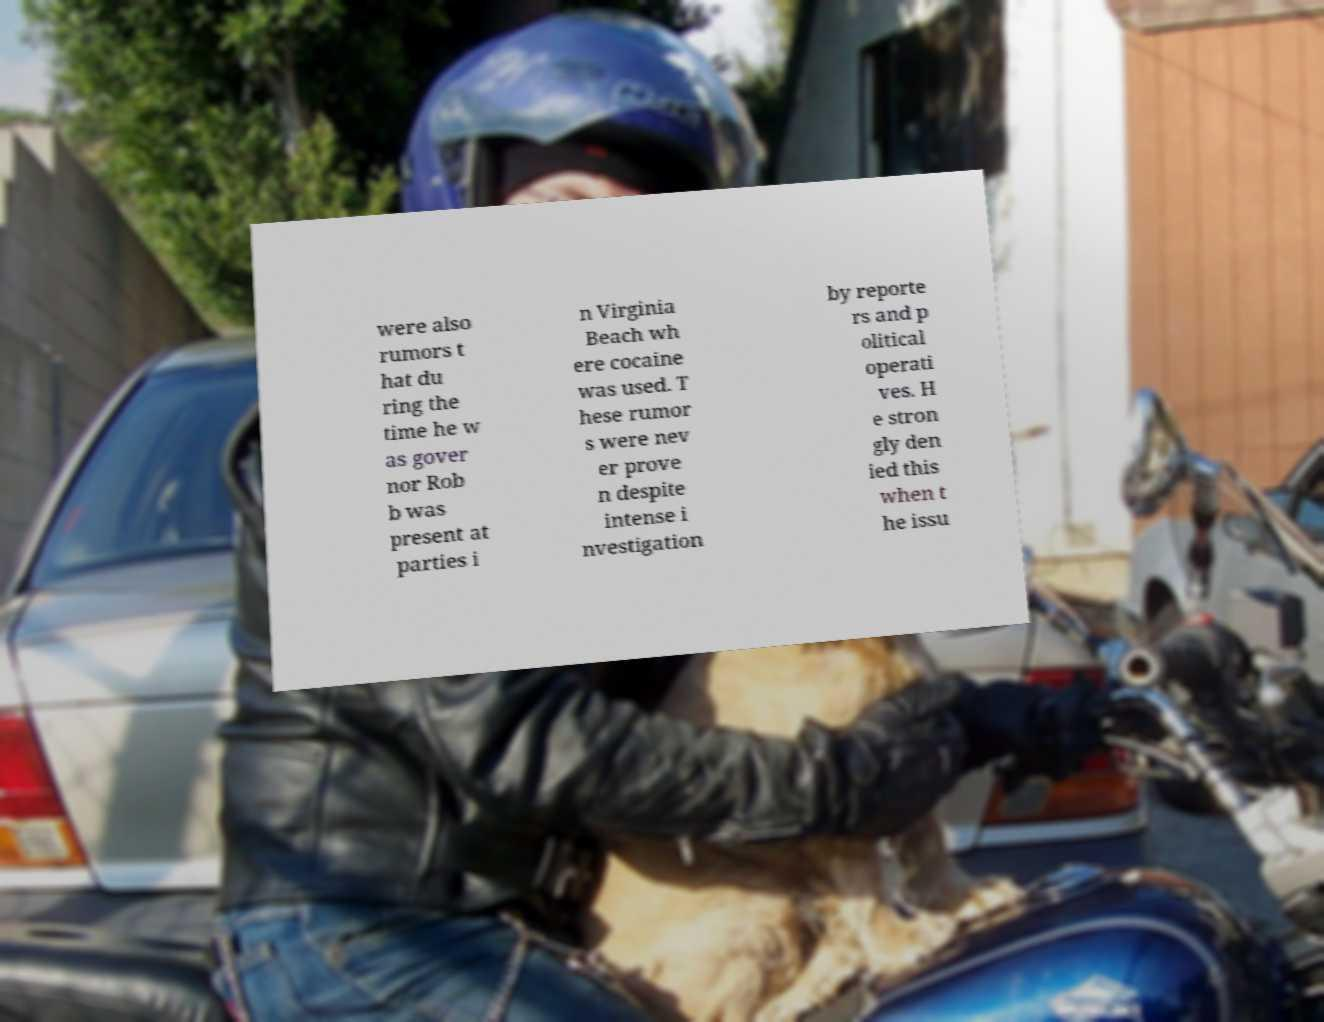Please identify and transcribe the text found in this image. were also rumors t hat du ring the time he w as gover nor Rob b was present at parties i n Virginia Beach wh ere cocaine was used. T hese rumor s were nev er prove n despite intense i nvestigation by reporte rs and p olitical operati ves. H e stron gly den ied this when t he issu 